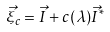<formula> <loc_0><loc_0><loc_500><loc_500>\vec { \xi } _ { c } = \vec { I } + c ( \lambda ) \vec { I } ^ { * }</formula> 